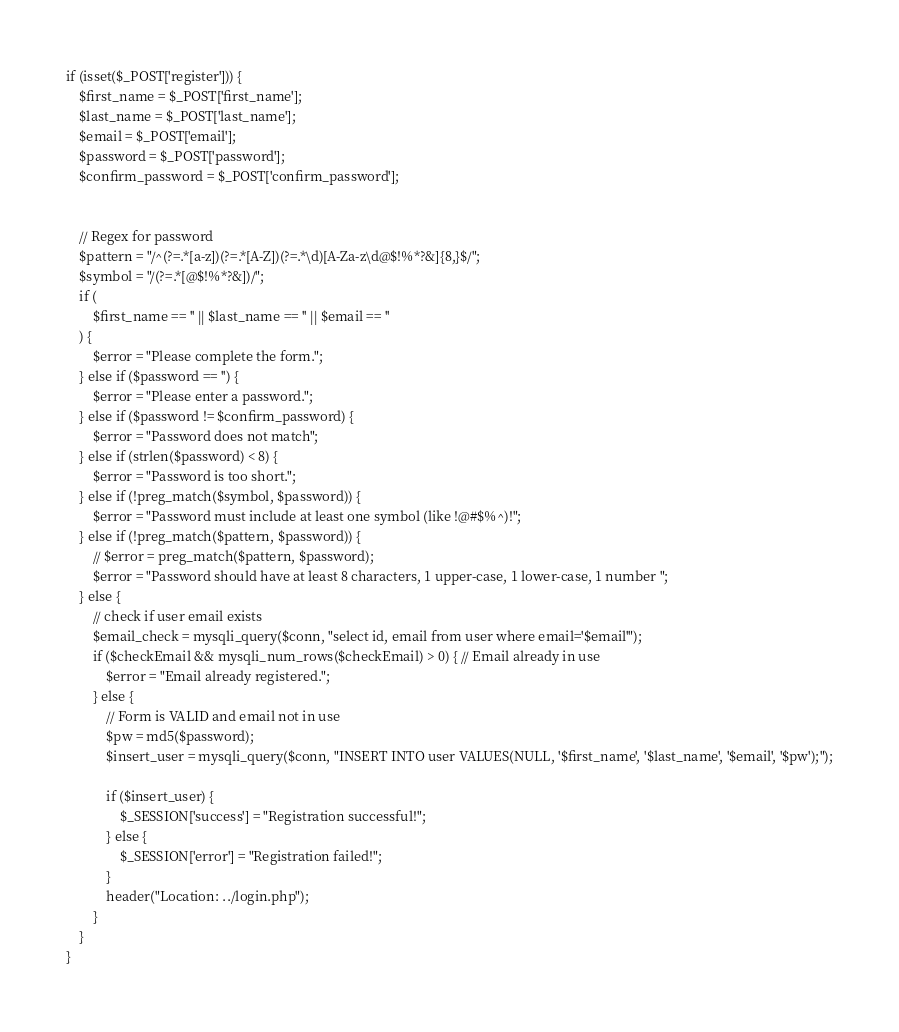Convert code to text. <code><loc_0><loc_0><loc_500><loc_500><_PHP_>

if (isset($_POST['register'])) {
    $first_name = $_POST['first_name'];
    $last_name = $_POST['last_name'];
    $email = $_POST['email'];
    $password = $_POST['password'];
    $confirm_password = $_POST['confirm_password'];


    // Regex for password
    $pattern = "/^(?=.*[a-z])(?=.*[A-Z])(?=.*\d)[A-Za-z\d@$!%*?&]{8,}$/";
    $symbol = "/(?=.*[@$!%*?&])/";
    if (
        $first_name == '' || $last_name == '' || $email == ''
    ) {
        $error = "Please complete the form.";
    } else if ($password == '') {
        $error = "Please enter a password.";
    } else if ($password != $confirm_password) {
        $error = "Password does not match";
    } else if (strlen($password) < 8) {
        $error = "Password is too short.";
    } else if (!preg_match($symbol, $password)) {
        $error = "Password must include at least one symbol (like !@#$%^)!";
    } else if (!preg_match($pattern, $password)) {
        // $error = preg_match($pattern, $password);
        $error = "Password should have at least 8 characters, 1 upper-case, 1 lower-case, 1 number ";
    } else {
        // check if user email exists
        $email_check = mysqli_query($conn, "select id, email from user where email='$email'");
        if ($checkEmail && mysqli_num_rows($checkEmail) > 0) { // Email already in use
            $error = "Email already registered.";
        } else {
            // Form is VALID and email not in use
            $pw = md5($password);
            $insert_user = mysqli_query($conn, "INSERT INTO user VALUES(NULL, '$first_name', '$last_name', '$email', '$pw');");

            if ($insert_user) {
                $_SESSION['success'] = "Registration successful!";
            } else {
                $_SESSION['error'] = "Registration failed!";
            }
            header("Location: ../login.php");
        }
    }
}
</code> 